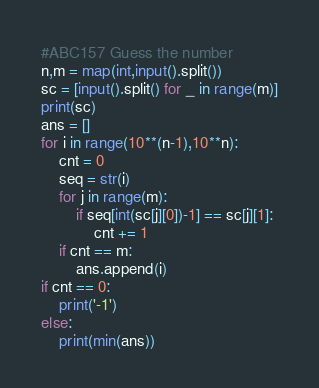<code> <loc_0><loc_0><loc_500><loc_500><_Python_>#ABC157 Guess the number
n,m = map(int,input().split())
sc = [input().split() for _ in range(m)]
print(sc)
ans = []
for i in range(10**(n-1),10**n):
    cnt = 0
    seq = str(i)
    for j in range(m):
        if seq[int(sc[j][0])-1] == sc[j][1]:
            cnt += 1
    if cnt == m:
        ans.append(i)
if cnt == 0:
    print('-1')
else:
    print(min(ans))</code> 